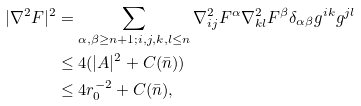<formula> <loc_0><loc_0><loc_500><loc_500>| \nabla ^ { 2 } F | ^ { 2 } & = \sum _ { \alpha , \beta \geq n + 1 ; i , j , k , l \leq n } \nabla ^ { 2 } _ { i j } F ^ { \alpha } \nabla ^ { 2 } _ { k l } F ^ { \beta } \delta _ { \alpha \beta } g ^ { i k } g ^ { j l } \\ & \leq 4 ( | A | ^ { 2 } + C ( \bar { n } ) ) \\ & \leq 4 r _ { 0 } ^ { - 2 } + C ( \bar { n } ) ,</formula> 